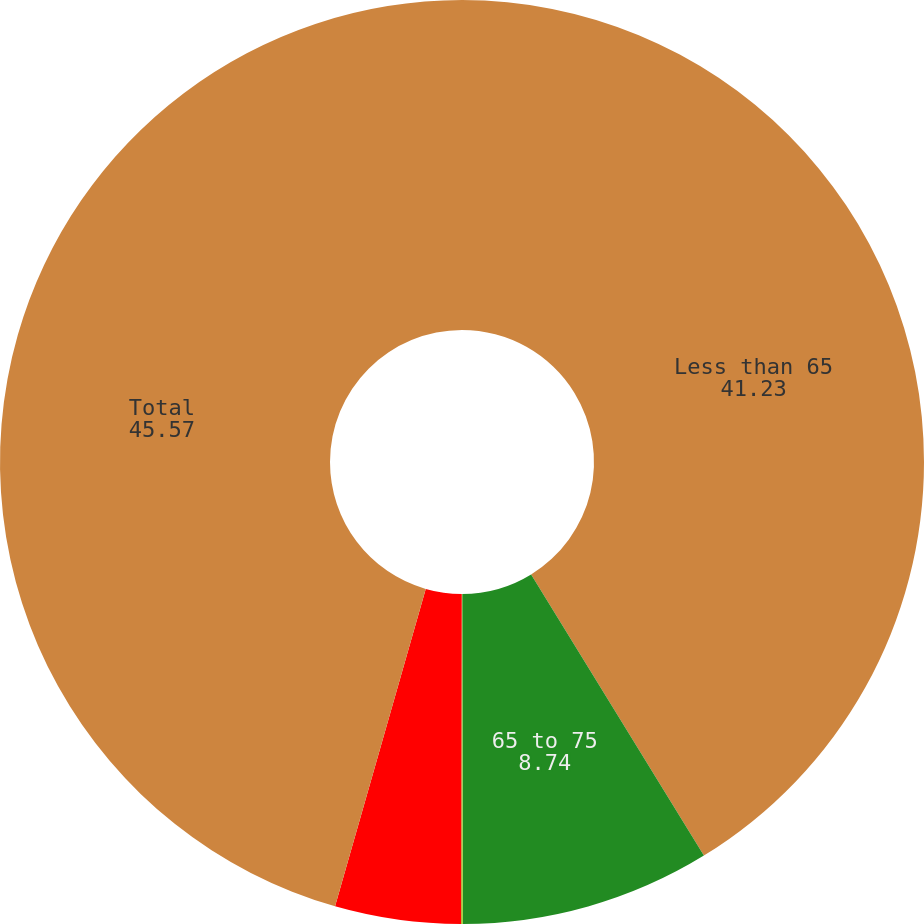<chart> <loc_0><loc_0><loc_500><loc_500><pie_chart><fcel>Less than 65<fcel>65 to 75<fcel>76 to 80<fcel>Greater than 80<fcel>Total<nl><fcel>41.23%<fcel>8.74%<fcel>0.06%<fcel>4.4%<fcel>45.57%<nl></chart> 